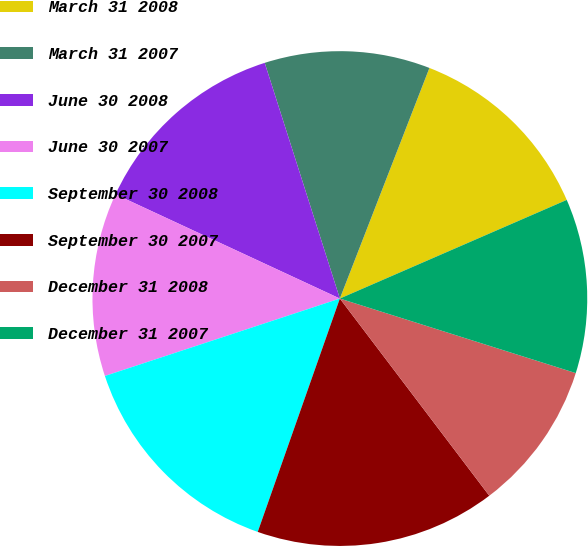Convert chart. <chart><loc_0><loc_0><loc_500><loc_500><pie_chart><fcel>March 31 2008<fcel>March 31 2007<fcel>June 30 2008<fcel>June 30 2007<fcel>September 30 2008<fcel>September 30 2007<fcel>December 31 2008<fcel>December 31 2007<nl><fcel>12.58%<fcel>10.81%<fcel>13.17%<fcel>11.99%<fcel>14.55%<fcel>15.71%<fcel>9.81%<fcel>11.4%<nl></chart> 